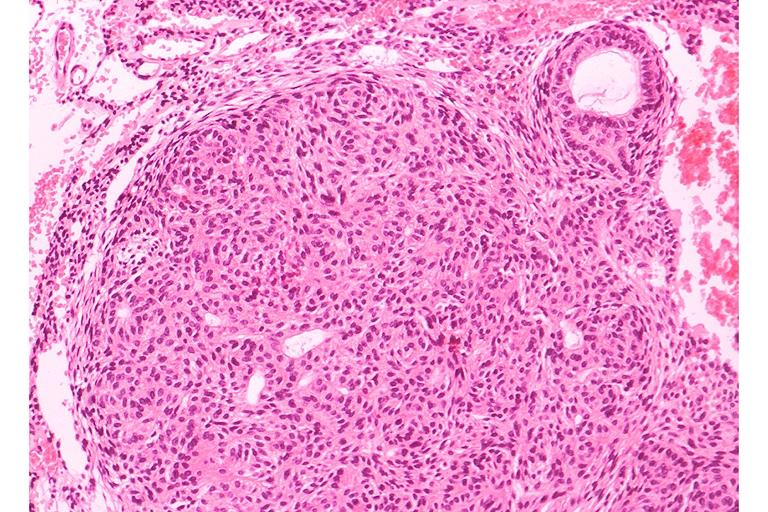what does this image show?
Answer the question using a single word or phrase. Adenomatoid odontogenic tumor 